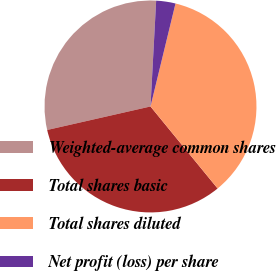Convert chart. <chart><loc_0><loc_0><loc_500><loc_500><pie_chart><fcel>Weighted-average common shares<fcel>Total shares basic<fcel>Total shares diluted<fcel>Net profit (loss) per share<nl><fcel>29.41%<fcel>32.35%<fcel>35.29%<fcel>2.94%<nl></chart> 